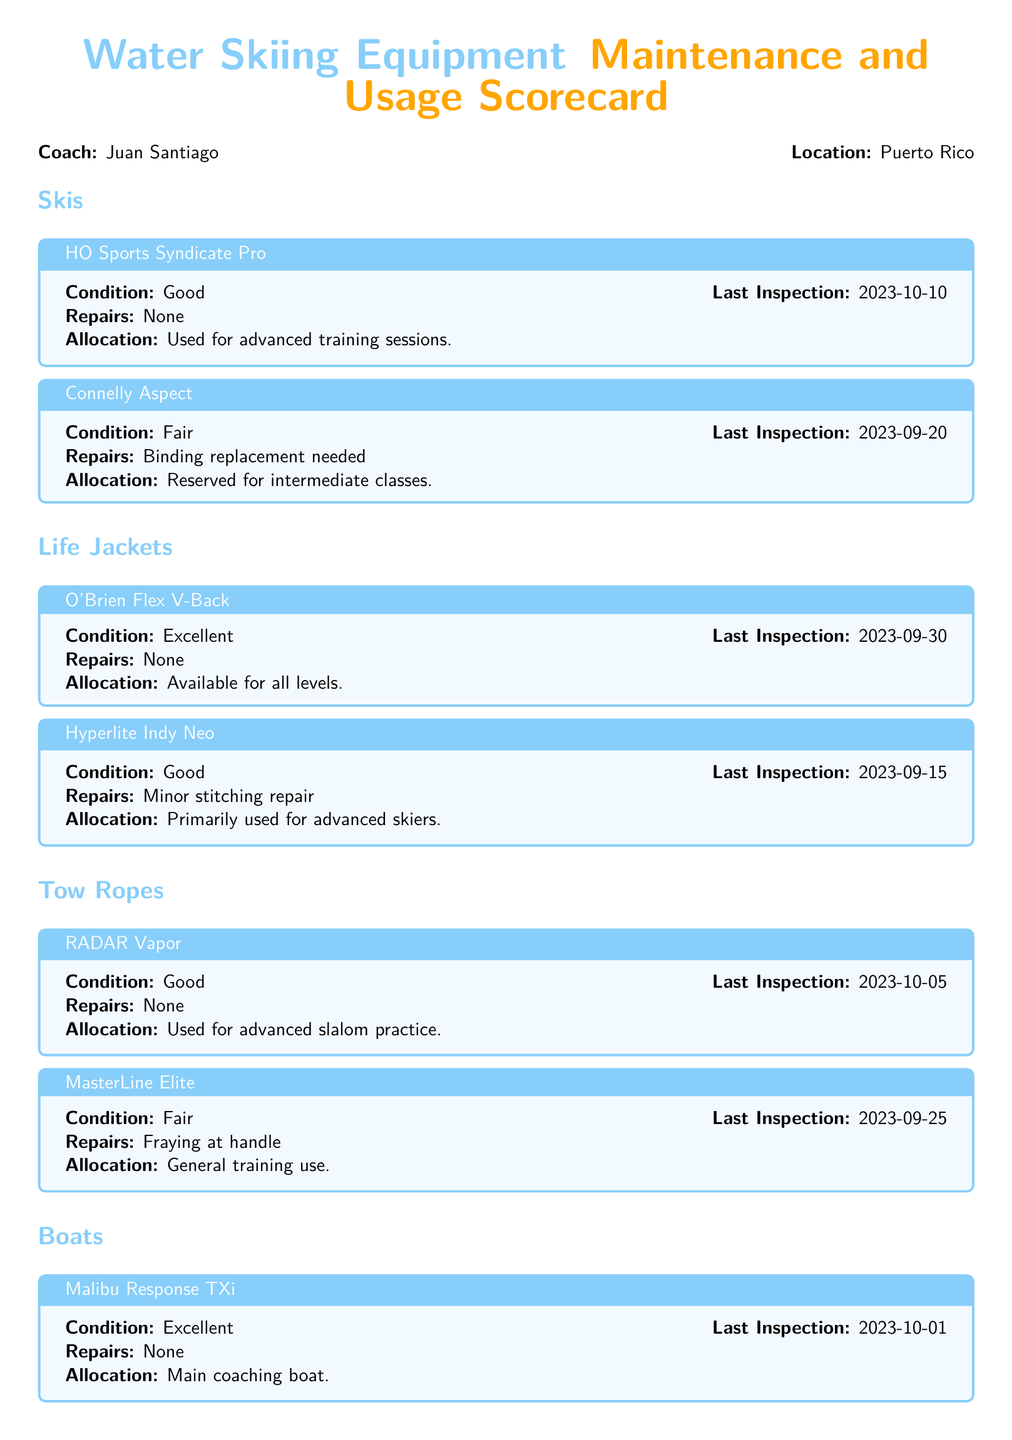What is the condition of the HO Sports Syndicate Pro skis? The condition is stated as "Good" in the document.
Answer: Good When was the last inspection of the Connelly Aspect? The date of the last inspection is provided as "2023-09-20."
Answer: 2023-09-20 What type of repairs does the Hyperlite Indy Neo life jacket need? The document mentions "Minor stitching repair" as the needed repair.
Answer: Minor stitching repair Which boat is the main coaching boat? The document specifies that the "Malibu Response TXi" is the main coaching boat.
Answer: Malibu Response TXi What is the allocation for the MasterLine Elite tow rope? The allocation is described as "General training use."
Answer: General training use How many skis are listed in the document? The document lists a total of two skis under the "Skis" section.
Answer: 2 What is the condition of the Nautique 200 boat? The condition is described as "Good" in the scorecard.
Answer: Good What is the most recent evaluation date for the O'Brien Flex V-Back life jacket? The evaluation date provided is "2023-09-30."
Answer: 2023-09-30 What repair is required for the Connelly Aspect skis? The document states that "Binding replacement needed" for the skis.
Answer: Binding replacement needed 